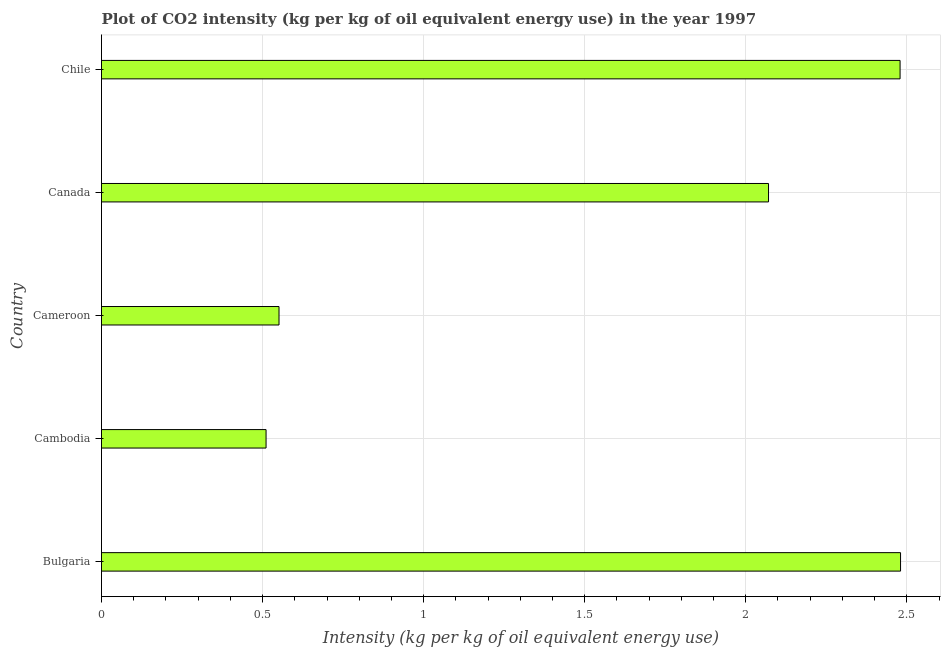Does the graph contain any zero values?
Offer a terse response. No. What is the title of the graph?
Keep it short and to the point. Plot of CO2 intensity (kg per kg of oil equivalent energy use) in the year 1997. What is the label or title of the X-axis?
Your response must be concise. Intensity (kg per kg of oil equivalent energy use). What is the label or title of the Y-axis?
Ensure brevity in your answer.  Country. What is the co2 intensity in Chile?
Your response must be concise. 2.48. Across all countries, what is the maximum co2 intensity?
Your answer should be compact. 2.48. Across all countries, what is the minimum co2 intensity?
Your response must be concise. 0.51. In which country was the co2 intensity maximum?
Give a very brief answer. Bulgaria. In which country was the co2 intensity minimum?
Keep it short and to the point. Cambodia. What is the sum of the co2 intensity?
Make the answer very short. 8.09. What is the difference between the co2 intensity in Canada and Chile?
Your answer should be very brief. -0.41. What is the average co2 intensity per country?
Give a very brief answer. 1.62. What is the median co2 intensity?
Make the answer very short. 2.07. What is the ratio of the co2 intensity in Canada to that in Chile?
Make the answer very short. 0.83. Is the co2 intensity in Bulgaria less than that in Cambodia?
Make the answer very short. No. What is the difference between the highest and the second highest co2 intensity?
Offer a terse response. 0. Is the sum of the co2 intensity in Cambodia and Cameroon greater than the maximum co2 intensity across all countries?
Ensure brevity in your answer.  No. What is the difference between the highest and the lowest co2 intensity?
Make the answer very short. 1.97. In how many countries, is the co2 intensity greater than the average co2 intensity taken over all countries?
Ensure brevity in your answer.  3. Are all the bars in the graph horizontal?
Ensure brevity in your answer.  Yes. How many countries are there in the graph?
Ensure brevity in your answer.  5. What is the difference between two consecutive major ticks on the X-axis?
Your response must be concise. 0.5. What is the Intensity (kg per kg of oil equivalent energy use) of Bulgaria?
Provide a succinct answer. 2.48. What is the Intensity (kg per kg of oil equivalent energy use) of Cambodia?
Your answer should be compact. 0.51. What is the Intensity (kg per kg of oil equivalent energy use) in Cameroon?
Give a very brief answer. 0.55. What is the Intensity (kg per kg of oil equivalent energy use) in Canada?
Your answer should be compact. 2.07. What is the Intensity (kg per kg of oil equivalent energy use) of Chile?
Ensure brevity in your answer.  2.48. What is the difference between the Intensity (kg per kg of oil equivalent energy use) in Bulgaria and Cambodia?
Keep it short and to the point. 1.97. What is the difference between the Intensity (kg per kg of oil equivalent energy use) in Bulgaria and Cameroon?
Your answer should be compact. 1.93. What is the difference between the Intensity (kg per kg of oil equivalent energy use) in Bulgaria and Canada?
Offer a terse response. 0.41. What is the difference between the Intensity (kg per kg of oil equivalent energy use) in Bulgaria and Chile?
Provide a succinct answer. 0. What is the difference between the Intensity (kg per kg of oil equivalent energy use) in Cambodia and Cameroon?
Offer a very short reply. -0.04. What is the difference between the Intensity (kg per kg of oil equivalent energy use) in Cambodia and Canada?
Ensure brevity in your answer.  -1.56. What is the difference between the Intensity (kg per kg of oil equivalent energy use) in Cambodia and Chile?
Ensure brevity in your answer.  -1.97. What is the difference between the Intensity (kg per kg of oil equivalent energy use) in Cameroon and Canada?
Give a very brief answer. -1.52. What is the difference between the Intensity (kg per kg of oil equivalent energy use) in Cameroon and Chile?
Keep it short and to the point. -1.93. What is the difference between the Intensity (kg per kg of oil equivalent energy use) in Canada and Chile?
Your answer should be very brief. -0.41. What is the ratio of the Intensity (kg per kg of oil equivalent energy use) in Bulgaria to that in Cambodia?
Your answer should be compact. 4.86. What is the ratio of the Intensity (kg per kg of oil equivalent energy use) in Bulgaria to that in Cameroon?
Your answer should be compact. 4.5. What is the ratio of the Intensity (kg per kg of oil equivalent energy use) in Bulgaria to that in Canada?
Offer a terse response. 1.2. What is the ratio of the Intensity (kg per kg of oil equivalent energy use) in Cambodia to that in Cameroon?
Your answer should be compact. 0.93. What is the ratio of the Intensity (kg per kg of oil equivalent energy use) in Cambodia to that in Canada?
Offer a very short reply. 0.25. What is the ratio of the Intensity (kg per kg of oil equivalent energy use) in Cambodia to that in Chile?
Your answer should be very brief. 0.21. What is the ratio of the Intensity (kg per kg of oil equivalent energy use) in Cameroon to that in Canada?
Ensure brevity in your answer.  0.27. What is the ratio of the Intensity (kg per kg of oil equivalent energy use) in Cameroon to that in Chile?
Your answer should be very brief. 0.22. What is the ratio of the Intensity (kg per kg of oil equivalent energy use) in Canada to that in Chile?
Give a very brief answer. 0.83. 